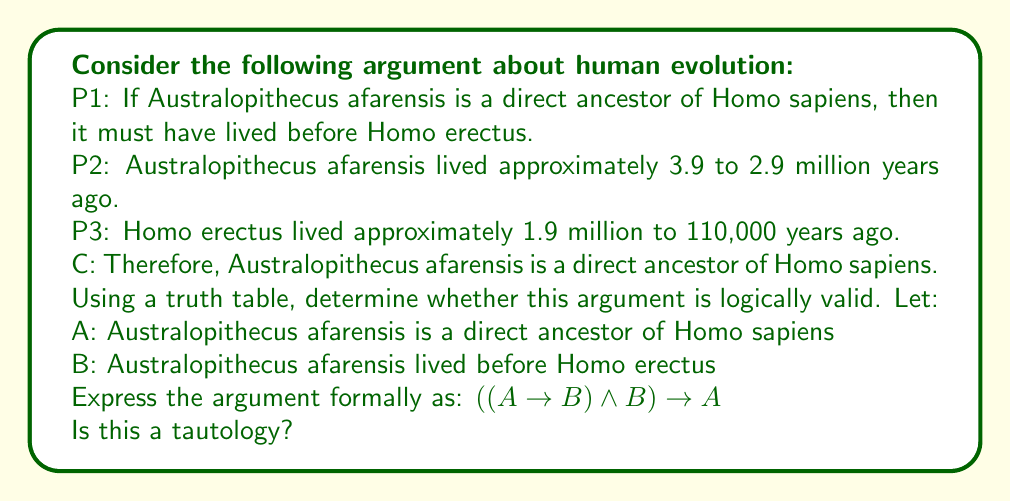Help me with this question. To determine if the argument is logically valid, we need to construct a truth table for the formal expression $((A \rightarrow B) \land B) \rightarrow A$ and check if it's a tautology (always true regardless of the truth values of A and B).

Let's construct the truth table:

$$
\begin{array}{|c|c|c|c|c|c|}
\hline
A & B & A \rightarrow B & (A \rightarrow B) \land B & ((A \rightarrow B) \land B) \rightarrow A \\
\hline
T & T & T & T & T \\
T & F & F & F & T \\
F & T & T & T & F \\
F & F & T & F & T \\
\hline
\end{array}
$$

Step-by-step explanation:

1. We start by listing all possible combinations of truth values for A and B.
2. We then calculate $A \rightarrow B$:
   - True when A is false or B is true
   - False when A is true and B is false
3. Next, we calculate $(A \rightarrow B) \land B$:
   - True only when both $(A \rightarrow B)$ and B are true
4. Finally, we calculate $((A \rightarrow B) \land B) \rightarrow A$:
   - True when the left side is false or A is true
   - False when the left side is true and A is false

Looking at the final column, we see that the expression is not always true. Specifically, when A is false and B is true, the entire expression evaluates to false.

This means the argument is not logically valid. The conclusion (A) doesn't necessarily follow from the premises, even if they are all true. In terms of the original argument, just because Australopithecus afarensis lived before Homo erectus doesn't necessarily mean it's a direct ancestor of Homo sapiens. There could be other explanations or evolutionary pathways.
Answer: No, the argument is not logically valid. The formal expression $((A \rightarrow B) \land B) \rightarrow A$ is not a tautology, as shown by the truth table where it evaluates to false when A is false and B is true. 